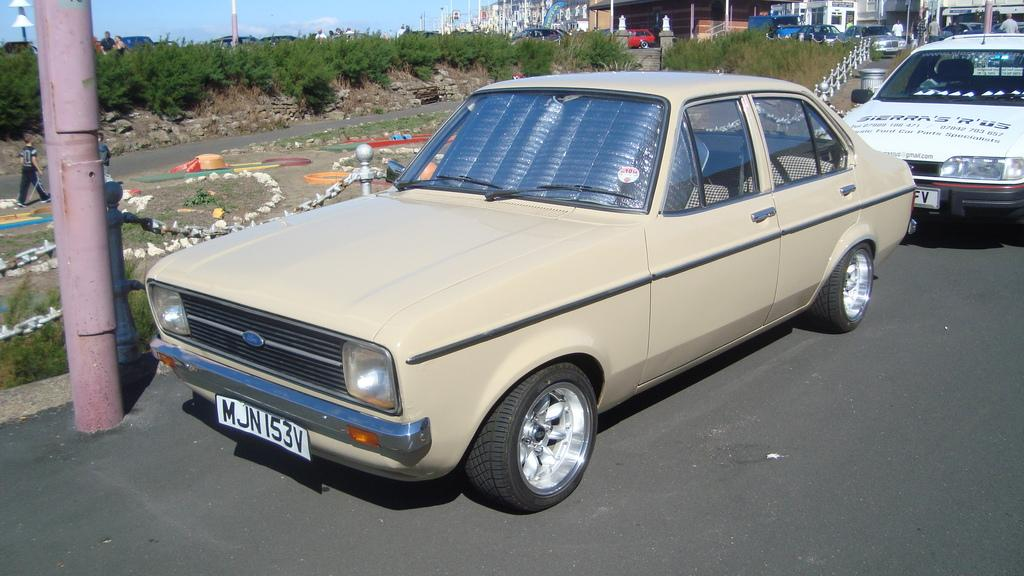What can be seen on the road in the image? There are vehicles on the road in the image. What separates the lanes of traffic in the image? There are divider poles in the image. What can be seen in the distance in the image? There are trees and buildings in the background of the image. Are there any people visible in the image? Yes, there are people in the background of the image. Can you tell me how many farmers are using spades in the image? There are no farmers or spades present in the image. What type of sidewalk can be seen in the image? There is no sidewalk visible in the image. 